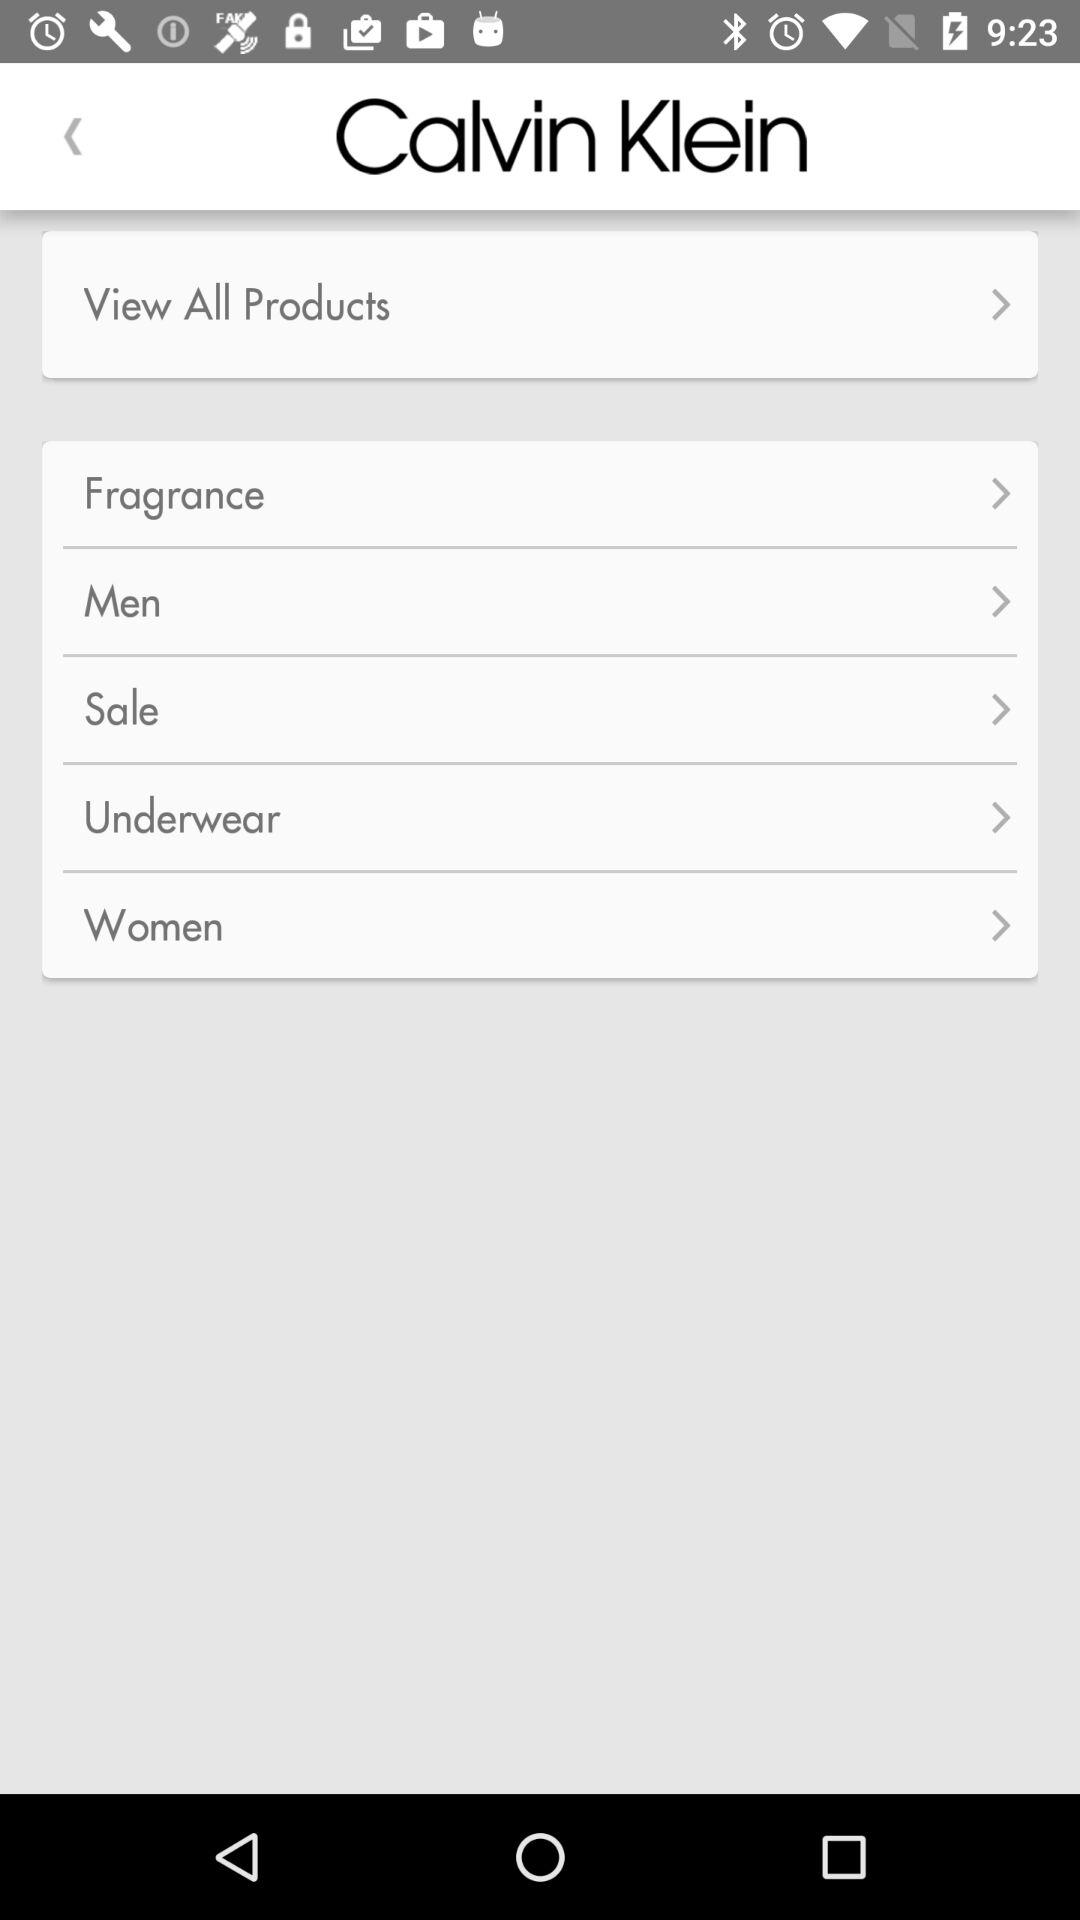What is the name of the product?
When the provided information is insufficient, respond with <no answer>. <no answer> 